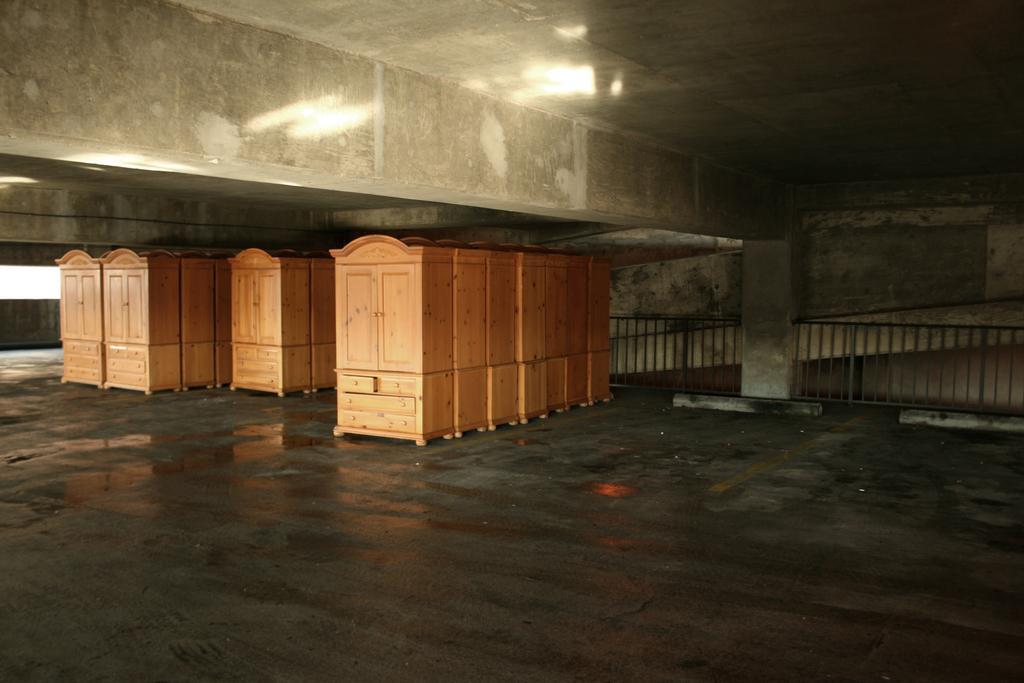Can you describe this image briefly? In this image we can see shelves. In the back there is a pillar and railing. 